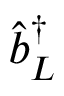<formula> <loc_0><loc_0><loc_500><loc_500>\hat { b } _ { L } ^ { \dagger }</formula> 